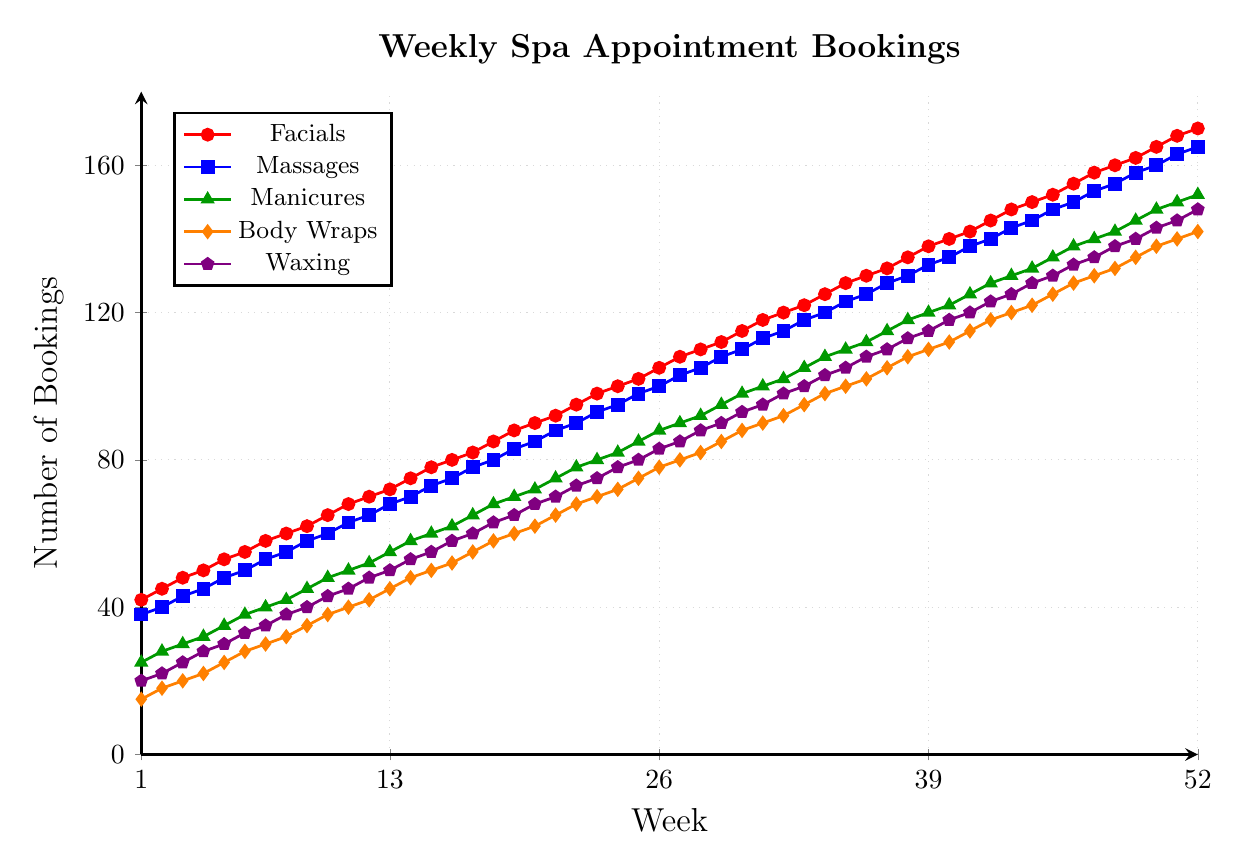Which treatment type starts with the lowest number of weekly bookings in Week 1? Look at the values for Week 1 across all treatment types and identify the lowest which is Body Wraps with 15 bookings
Answer: Body Wraps By how many weekly bookings do Facials increase from Week 1 to Week 52? Subtract the number of bookings in Week 1 from the bookings in Week 52: (170 - 42)
Answer: 128 Which treatment had the highest number of weekly bookings at the end of the year? Identify the booking values of all treatments in Week 52 and find the highest which is Facials with 170
Answer: Facials How many weekly bookings did Massages have in Week 30? Trace the value for Massages at Week 30 in the figure, which is 110
Answer: 110 Between which weeks do Manicures surpass 100 weekly bookings? Identify the weeks where Manicures go from below 100 to above 100: between Week 31 and Week 32 (100 and 102)
Answer: Between Week 31 and Week 32 Which treatment had the most consistent (least variable) booking increase over the year? Compare the patterns and slopes of all the treatments' lines. Waxing has the most consistent upward slope.
Answer: Waxing How much did Body Wraps' weekly bookings grow from Week 10 to Week 40? Subtract the number of bookings in Week 10 from Week 40: (112 - 38)
Answer: 74 From Week 20 to Week 30, which treatment type saw the greatest increase in weekly bookings? Calculate the difference for each treatment between Week 20 and Week 30, and find the maximum value. Facials increased from 90 to 115, which is 25
Answer: Facials What was the rate of increase in weekly bookings for Waxing from Week 1 to Week 52? Compute the difference for Waxing from Week 1 to Week 52 and divide by 52 weeks: (148 - 20) / 52
Answer: 2.46 Which treatment types had their weekly bookings double by the end of Week 52 compared to Week 1? For each treatment type, check if the Week 52 value is at least double the Week 1 value: Facials (170 >= 84), Massages (165 >= 76), Manicures (152 >= 50), Body Wraps (142 >= 30), Waxing (148 >= 40). All treatments meet this condition.
Answer: All 